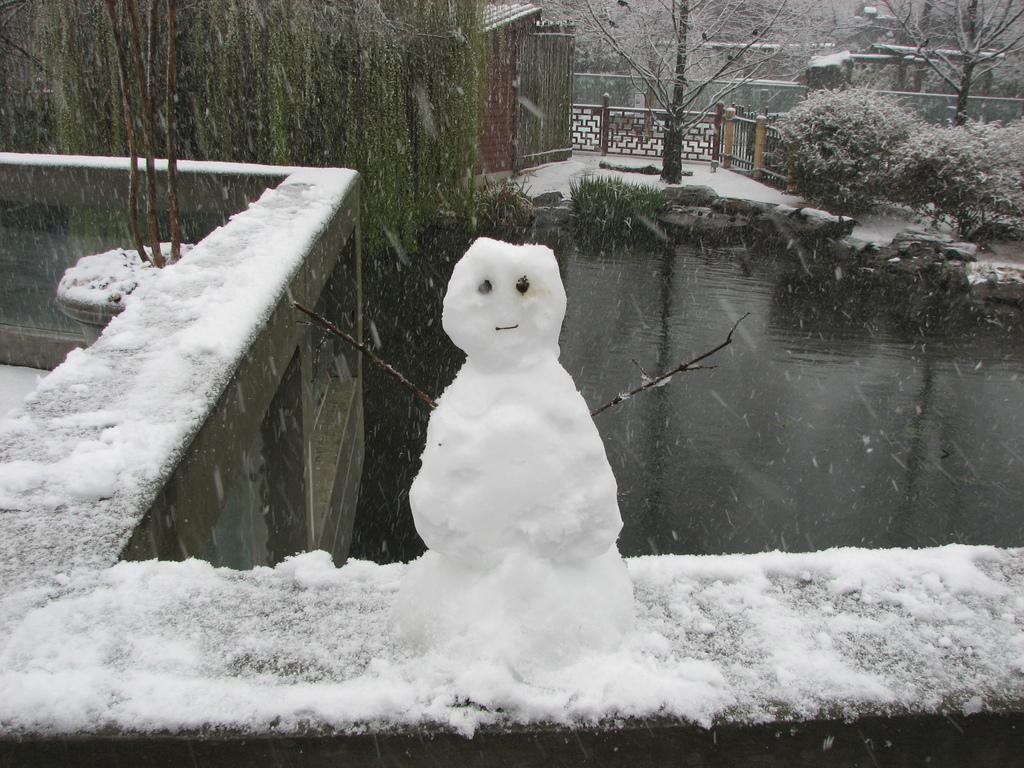What is the main subject of the image? There is a snowman in the image. What is the environment like in the image? There is snow in the image, suggesting a winter setting. What structures can be seen in the image? There is a fence and a house in the image. What natural elements are present in the image? There are rocks, trees, and water visible in the image. How many cattle can be seen grazing near the lake in the image? There is no lake or cattle present in the image. What type of precipitation is falling from the sky in the image? The image does not depict any precipitation, such as sleet, falling from the sky. 